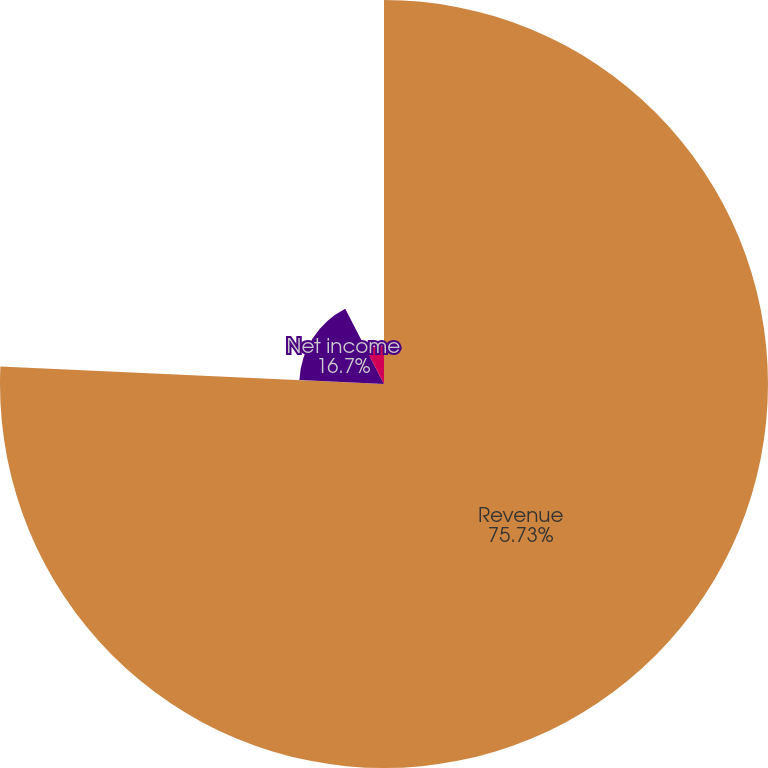<chart> <loc_0><loc_0><loc_500><loc_500><pie_chart><fcel>Revenue<fcel>Net income<fcel>Basic net income per common<fcel>Diluted net income per common<nl><fcel>75.73%<fcel>16.7%<fcel>7.57%<fcel>0.0%<nl></chart> 